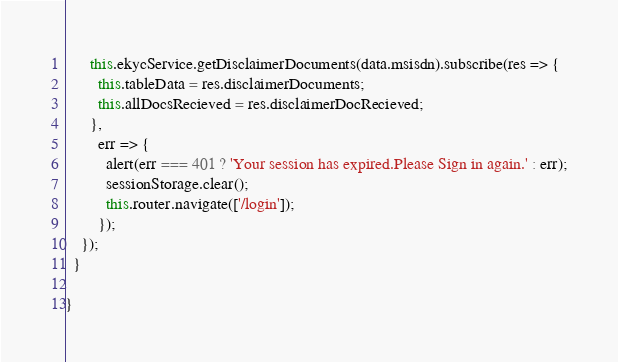<code> <loc_0><loc_0><loc_500><loc_500><_TypeScript_>      this.ekycService.getDisclaimerDocuments(data.msisdn).subscribe(res => {
        this.tableData = res.disclaimerDocuments;
        this.allDocsRecieved = res.disclaimerDocRecieved;
      },
        err => {
          alert(err === 401 ? 'Your session has expired.Please Sign in again.' : err);
          sessionStorage.clear();
          this.router.navigate(['/login']);
        });
    });
  }

}
</code> 